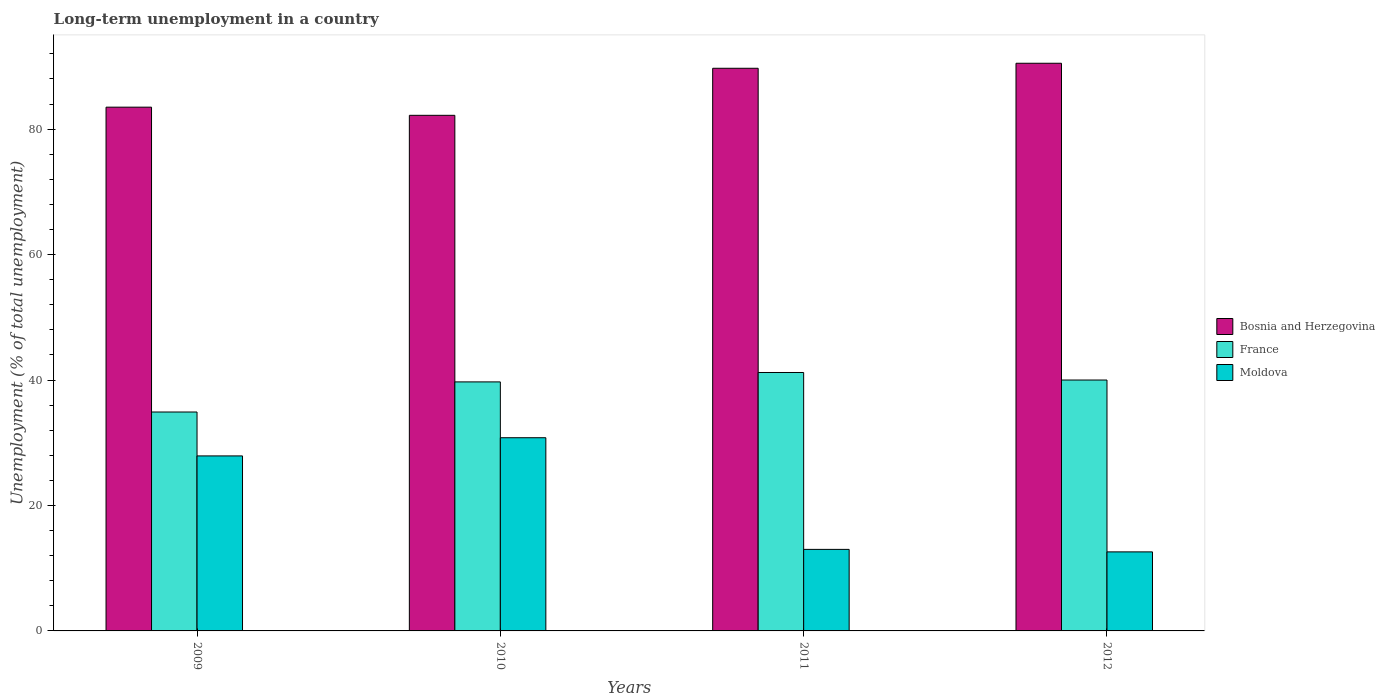How many different coloured bars are there?
Your answer should be very brief. 3. How many groups of bars are there?
Give a very brief answer. 4. Are the number of bars per tick equal to the number of legend labels?
Keep it short and to the point. Yes. How many bars are there on the 1st tick from the right?
Provide a short and direct response. 3. What is the label of the 3rd group of bars from the left?
Provide a short and direct response. 2011. What is the percentage of long-term unemployed population in Moldova in 2009?
Your answer should be very brief. 27.9. Across all years, what is the maximum percentage of long-term unemployed population in Moldova?
Offer a terse response. 30.8. Across all years, what is the minimum percentage of long-term unemployed population in Moldova?
Provide a succinct answer. 12.6. In which year was the percentage of long-term unemployed population in Moldova maximum?
Provide a succinct answer. 2010. In which year was the percentage of long-term unemployed population in France minimum?
Make the answer very short. 2009. What is the total percentage of long-term unemployed population in Moldova in the graph?
Make the answer very short. 84.3. What is the difference between the percentage of long-term unemployed population in Moldova in 2009 and that in 2010?
Your answer should be compact. -2.9. What is the difference between the percentage of long-term unemployed population in France in 2011 and the percentage of long-term unemployed population in Bosnia and Herzegovina in 2010?
Make the answer very short. -41. What is the average percentage of long-term unemployed population in Moldova per year?
Give a very brief answer. 21.07. In the year 2012, what is the difference between the percentage of long-term unemployed population in Moldova and percentage of long-term unemployed population in Bosnia and Herzegovina?
Provide a succinct answer. -77.9. What is the ratio of the percentage of long-term unemployed population in Moldova in 2009 to that in 2011?
Your answer should be very brief. 2.15. Is the percentage of long-term unemployed population in France in 2009 less than that in 2011?
Make the answer very short. Yes. What is the difference between the highest and the second highest percentage of long-term unemployed population in France?
Offer a terse response. 1.2. What is the difference between the highest and the lowest percentage of long-term unemployed population in France?
Your answer should be compact. 6.3. What does the 3rd bar from the left in 2012 represents?
Your answer should be very brief. Moldova. What does the 2nd bar from the right in 2009 represents?
Keep it short and to the point. France. Is it the case that in every year, the sum of the percentage of long-term unemployed population in Bosnia and Herzegovina and percentage of long-term unemployed population in Moldova is greater than the percentage of long-term unemployed population in France?
Make the answer very short. Yes. Are all the bars in the graph horizontal?
Offer a very short reply. No. What is the difference between two consecutive major ticks on the Y-axis?
Give a very brief answer. 20. Are the values on the major ticks of Y-axis written in scientific E-notation?
Your response must be concise. No. Does the graph contain grids?
Offer a terse response. No. How many legend labels are there?
Provide a succinct answer. 3. How are the legend labels stacked?
Offer a terse response. Vertical. What is the title of the graph?
Make the answer very short. Long-term unemployment in a country. Does "Middle East & North Africa (developing only)" appear as one of the legend labels in the graph?
Offer a terse response. No. What is the label or title of the X-axis?
Your response must be concise. Years. What is the label or title of the Y-axis?
Your answer should be very brief. Unemployment (% of total unemployment). What is the Unemployment (% of total unemployment) of Bosnia and Herzegovina in 2009?
Your answer should be very brief. 83.5. What is the Unemployment (% of total unemployment) of France in 2009?
Offer a terse response. 34.9. What is the Unemployment (% of total unemployment) of Moldova in 2009?
Your response must be concise. 27.9. What is the Unemployment (% of total unemployment) of Bosnia and Herzegovina in 2010?
Offer a terse response. 82.2. What is the Unemployment (% of total unemployment) in France in 2010?
Give a very brief answer. 39.7. What is the Unemployment (% of total unemployment) of Moldova in 2010?
Offer a terse response. 30.8. What is the Unemployment (% of total unemployment) in Bosnia and Herzegovina in 2011?
Provide a short and direct response. 89.7. What is the Unemployment (% of total unemployment) in France in 2011?
Offer a terse response. 41.2. What is the Unemployment (% of total unemployment) of Moldova in 2011?
Keep it short and to the point. 13. What is the Unemployment (% of total unemployment) in Bosnia and Herzegovina in 2012?
Your answer should be very brief. 90.5. What is the Unemployment (% of total unemployment) in Moldova in 2012?
Provide a succinct answer. 12.6. Across all years, what is the maximum Unemployment (% of total unemployment) of Bosnia and Herzegovina?
Offer a very short reply. 90.5. Across all years, what is the maximum Unemployment (% of total unemployment) in France?
Your answer should be very brief. 41.2. Across all years, what is the maximum Unemployment (% of total unemployment) of Moldova?
Give a very brief answer. 30.8. Across all years, what is the minimum Unemployment (% of total unemployment) of Bosnia and Herzegovina?
Your answer should be compact. 82.2. Across all years, what is the minimum Unemployment (% of total unemployment) in France?
Your answer should be compact. 34.9. Across all years, what is the minimum Unemployment (% of total unemployment) in Moldova?
Make the answer very short. 12.6. What is the total Unemployment (% of total unemployment) of Bosnia and Herzegovina in the graph?
Give a very brief answer. 345.9. What is the total Unemployment (% of total unemployment) of France in the graph?
Make the answer very short. 155.8. What is the total Unemployment (% of total unemployment) in Moldova in the graph?
Offer a very short reply. 84.3. What is the difference between the Unemployment (% of total unemployment) of France in 2009 and that in 2010?
Give a very brief answer. -4.8. What is the difference between the Unemployment (% of total unemployment) of Moldova in 2009 and that in 2010?
Your answer should be compact. -2.9. What is the difference between the Unemployment (% of total unemployment) of Bosnia and Herzegovina in 2009 and that in 2011?
Provide a succinct answer. -6.2. What is the difference between the Unemployment (% of total unemployment) of Moldova in 2009 and that in 2011?
Offer a terse response. 14.9. What is the difference between the Unemployment (% of total unemployment) of Moldova in 2009 and that in 2012?
Provide a succinct answer. 15.3. What is the difference between the Unemployment (% of total unemployment) in France in 2010 and that in 2011?
Provide a succinct answer. -1.5. What is the difference between the Unemployment (% of total unemployment) of Bosnia and Herzegovina in 2010 and that in 2012?
Offer a terse response. -8.3. What is the difference between the Unemployment (% of total unemployment) in France in 2010 and that in 2012?
Give a very brief answer. -0.3. What is the difference between the Unemployment (% of total unemployment) of Bosnia and Herzegovina in 2011 and that in 2012?
Keep it short and to the point. -0.8. What is the difference between the Unemployment (% of total unemployment) of France in 2011 and that in 2012?
Make the answer very short. 1.2. What is the difference between the Unemployment (% of total unemployment) of Bosnia and Herzegovina in 2009 and the Unemployment (% of total unemployment) of France in 2010?
Offer a terse response. 43.8. What is the difference between the Unemployment (% of total unemployment) of Bosnia and Herzegovina in 2009 and the Unemployment (% of total unemployment) of Moldova in 2010?
Ensure brevity in your answer.  52.7. What is the difference between the Unemployment (% of total unemployment) in Bosnia and Herzegovina in 2009 and the Unemployment (% of total unemployment) in France in 2011?
Offer a terse response. 42.3. What is the difference between the Unemployment (% of total unemployment) in Bosnia and Herzegovina in 2009 and the Unemployment (% of total unemployment) in Moldova in 2011?
Provide a short and direct response. 70.5. What is the difference between the Unemployment (% of total unemployment) in France in 2009 and the Unemployment (% of total unemployment) in Moldova in 2011?
Make the answer very short. 21.9. What is the difference between the Unemployment (% of total unemployment) of Bosnia and Herzegovina in 2009 and the Unemployment (% of total unemployment) of France in 2012?
Your answer should be very brief. 43.5. What is the difference between the Unemployment (% of total unemployment) in Bosnia and Herzegovina in 2009 and the Unemployment (% of total unemployment) in Moldova in 2012?
Your answer should be very brief. 70.9. What is the difference between the Unemployment (% of total unemployment) in France in 2009 and the Unemployment (% of total unemployment) in Moldova in 2012?
Provide a short and direct response. 22.3. What is the difference between the Unemployment (% of total unemployment) of Bosnia and Herzegovina in 2010 and the Unemployment (% of total unemployment) of Moldova in 2011?
Make the answer very short. 69.2. What is the difference between the Unemployment (% of total unemployment) of France in 2010 and the Unemployment (% of total unemployment) of Moldova in 2011?
Your answer should be compact. 26.7. What is the difference between the Unemployment (% of total unemployment) of Bosnia and Herzegovina in 2010 and the Unemployment (% of total unemployment) of France in 2012?
Offer a very short reply. 42.2. What is the difference between the Unemployment (% of total unemployment) in Bosnia and Herzegovina in 2010 and the Unemployment (% of total unemployment) in Moldova in 2012?
Keep it short and to the point. 69.6. What is the difference between the Unemployment (% of total unemployment) of France in 2010 and the Unemployment (% of total unemployment) of Moldova in 2012?
Provide a short and direct response. 27.1. What is the difference between the Unemployment (% of total unemployment) of Bosnia and Herzegovina in 2011 and the Unemployment (% of total unemployment) of France in 2012?
Make the answer very short. 49.7. What is the difference between the Unemployment (% of total unemployment) in Bosnia and Herzegovina in 2011 and the Unemployment (% of total unemployment) in Moldova in 2012?
Your answer should be very brief. 77.1. What is the difference between the Unemployment (% of total unemployment) of France in 2011 and the Unemployment (% of total unemployment) of Moldova in 2012?
Your response must be concise. 28.6. What is the average Unemployment (% of total unemployment) in Bosnia and Herzegovina per year?
Provide a short and direct response. 86.47. What is the average Unemployment (% of total unemployment) in France per year?
Ensure brevity in your answer.  38.95. What is the average Unemployment (% of total unemployment) of Moldova per year?
Make the answer very short. 21.07. In the year 2009, what is the difference between the Unemployment (% of total unemployment) of Bosnia and Herzegovina and Unemployment (% of total unemployment) of France?
Give a very brief answer. 48.6. In the year 2009, what is the difference between the Unemployment (% of total unemployment) in Bosnia and Herzegovina and Unemployment (% of total unemployment) in Moldova?
Provide a succinct answer. 55.6. In the year 2009, what is the difference between the Unemployment (% of total unemployment) of France and Unemployment (% of total unemployment) of Moldova?
Keep it short and to the point. 7. In the year 2010, what is the difference between the Unemployment (% of total unemployment) of Bosnia and Herzegovina and Unemployment (% of total unemployment) of France?
Provide a succinct answer. 42.5. In the year 2010, what is the difference between the Unemployment (% of total unemployment) in Bosnia and Herzegovina and Unemployment (% of total unemployment) in Moldova?
Your answer should be compact. 51.4. In the year 2010, what is the difference between the Unemployment (% of total unemployment) of France and Unemployment (% of total unemployment) of Moldova?
Your answer should be compact. 8.9. In the year 2011, what is the difference between the Unemployment (% of total unemployment) of Bosnia and Herzegovina and Unemployment (% of total unemployment) of France?
Offer a very short reply. 48.5. In the year 2011, what is the difference between the Unemployment (% of total unemployment) of Bosnia and Herzegovina and Unemployment (% of total unemployment) of Moldova?
Ensure brevity in your answer.  76.7. In the year 2011, what is the difference between the Unemployment (% of total unemployment) in France and Unemployment (% of total unemployment) in Moldova?
Provide a short and direct response. 28.2. In the year 2012, what is the difference between the Unemployment (% of total unemployment) in Bosnia and Herzegovina and Unemployment (% of total unemployment) in France?
Offer a very short reply. 50.5. In the year 2012, what is the difference between the Unemployment (% of total unemployment) in Bosnia and Herzegovina and Unemployment (% of total unemployment) in Moldova?
Your answer should be compact. 77.9. In the year 2012, what is the difference between the Unemployment (% of total unemployment) of France and Unemployment (% of total unemployment) of Moldova?
Your answer should be compact. 27.4. What is the ratio of the Unemployment (% of total unemployment) in Bosnia and Herzegovina in 2009 to that in 2010?
Ensure brevity in your answer.  1.02. What is the ratio of the Unemployment (% of total unemployment) in France in 2009 to that in 2010?
Give a very brief answer. 0.88. What is the ratio of the Unemployment (% of total unemployment) in Moldova in 2009 to that in 2010?
Your answer should be compact. 0.91. What is the ratio of the Unemployment (% of total unemployment) of Bosnia and Herzegovina in 2009 to that in 2011?
Give a very brief answer. 0.93. What is the ratio of the Unemployment (% of total unemployment) of France in 2009 to that in 2011?
Keep it short and to the point. 0.85. What is the ratio of the Unemployment (% of total unemployment) in Moldova in 2009 to that in 2011?
Provide a short and direct response. 2.15. What is the ratio of the Unemployment (% of total unemployment) of Bosnia and Herzegovina in 2009 to that in 2012?
Keep it short and to the point. 0.92. What is the ratio of the Unemployment (% of total unemployment) of France in 2009 to that in 2012?
Offer a very short reply. 0.87. What is the ratio of the Unemployment (% of total unemployment) of Moldova in 2009 to that in 2012?
Provide a short and direct response. 2.21. What is the ratio of the Unemployment (% of total unemployment) of Bosnia and Herzegovina in 2010 to that in 2011?
Your response must be concise. 0.92. What is the ratio of the Unemployment (% of total unemployment) of France in 2010 to that in 2011?
Offer a terse response. 0.96. What is the ratio of the Unemployment (% of total unemployment) of Moldova in 2010 to that in 2011?
Make the answer very short. 2.37. What is the ratio of the Unemployment (% of total unemployment) in Bosnia and Herzegovina in 2010 to that in 2012?
Your answer should be compact. 0.91. What is the ratio of the Unemployment (% of total unemployment) of France in 2010 to that in 2012?
Your answer should be compact. 0.99. What is the ratio of the Unemployment (% of total unemployment) of Moldova in 2010 to that in 2012?
Ensure brevity in your answer.  2.44. What is the ratio of the Unemployment (% of total unemployment) in Bosnia and Herzegovina in 2011 to that in 2012?
Provide a succinct answer. 0.99. What is the ratio of the Unemployment (% of total unemployment) in France in 2011 to that in 2012?
Your answer should be very brief. 1.03. What is the ratio of the Unemployment (% of total unemployment) of Moldova in 2011 to that in 2012?
Your answer should be very brief. 1.03. What is the difference between the highest and the second highest Unemployment (% of total unemployment) in Bosnia and Herzegovina?
Provide a short and direct response. 0.8. What is the difference between the highest and the second highest Unemployment (% of total unemployment) of France?
Offer a very short reply. 1.2. What is the difference between the highest and the lowest Unemployment (% of total unemployment) in Bosnia and Herzegovina?
Your answer should be very brief. 8.3. What is the difference between the highest and the lowest Unemployment (% of total unemployment) of France?
Make the answer very short. 6.3. 